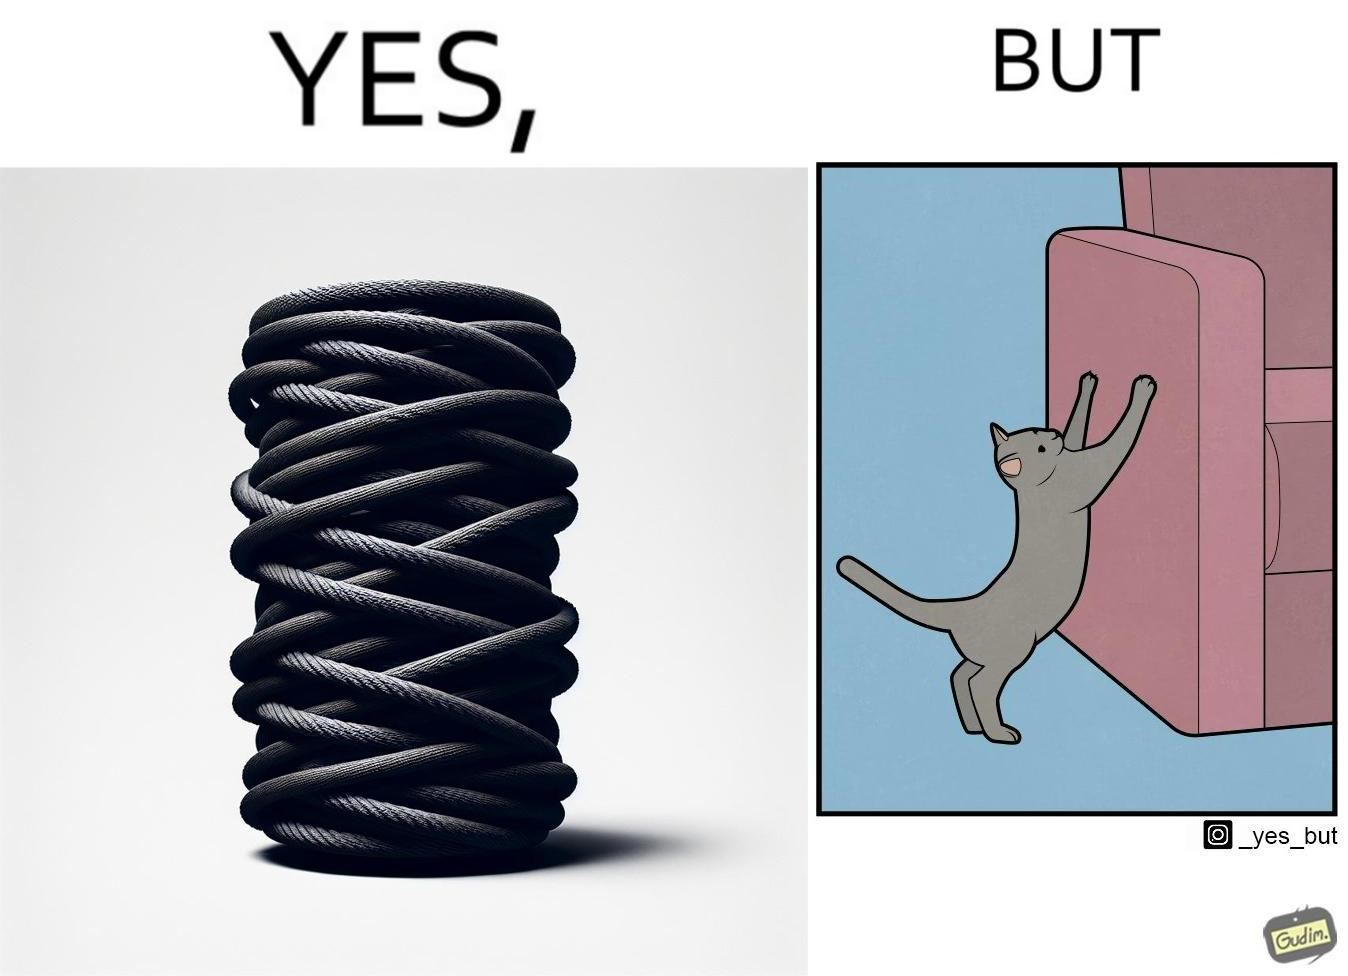What do you see in each half of this image? In the left part of the image: a cylindrical toy or some sort of thing  with a lots of rope wounded around its surface In the right part of the image: a cat scratching its nails over the sides of a sofa or trying to climb up the sofa 